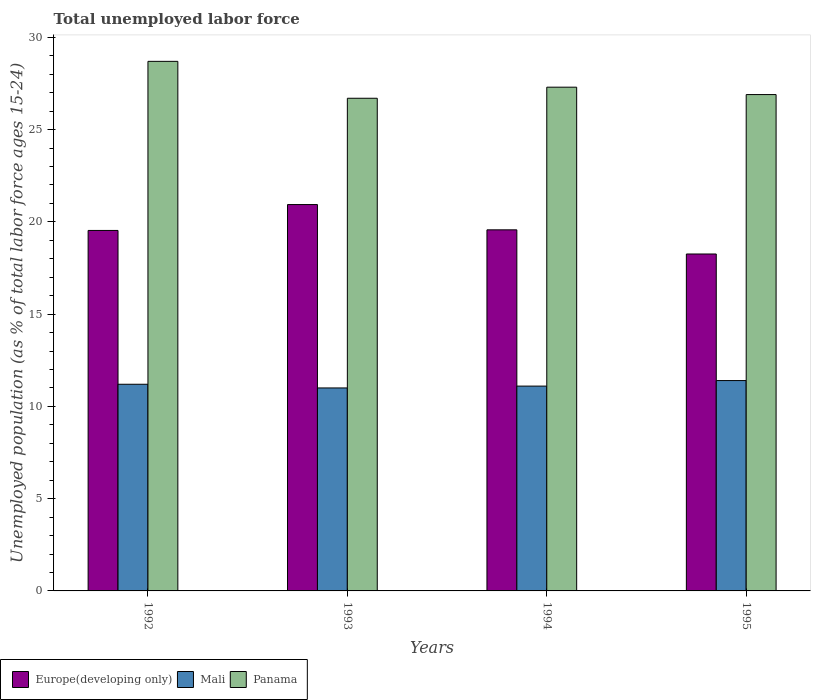How many groups of bars are there?
Provide a succinct answer. 4. Are the number of bars per tick equal to the number of legend labels?
Keep it short and to the point. Yes. Are the number of bars on each tick of the X-axis equal?
Provide a succinct answer. Yes. How many bars are there on the 3rd tick from the right?
Ensure brevity in your answer.  3. What is the label of the 4th group of bars from the left?
Offer a very short reply. 1995. In how many cases, is the number of bars for a given year not equal to the number of legend labels?
Give a very brief answer. 0. What is the percentage of unemployed population in in Europe(developing only) in 1994?
Make the answer very short. 19.57. Across all years, what is the maximum percentage of unemployed population in in Europe(developing only)?
Give a very brief answer. 20.94. Across all years, what is the minimum percentage of unemployed population in in Panama?
Your answer should be very brief. 26.7. In which year was the percentage of unemployed population in in Europe(developing only) maximum?
Give a very brief answer. 1993. In which year was the percentage of unemployed population in in Panama minimum?
Make the answer very short. 1993. What is the total percentage of unemployed population in in Mali in the graph?
Offer a terse response. 44.7. What is the difference between the percentage of unemployed population in in Mali in 1994 and that in 1995?
Provide a short and direct response. -0.3. What is the difference between the percentage of unemployed population in in Europe(developing only) in 1992 and the percentage of unemployed population in in Panama in 1994?
Provide a succinct answer. -7.76. What is the average percentage of unemployed population in in Mali per year?
Give a very brief answer. 11.17. In the year 1993, what is the difference between the percentage of unemployed population in in Europe(developing only) and percentage of unemployed population in in Mali?
Offer a very short reply. 9.94. In how many years, is the percentage of unemployed population in in Europe(developing only) greater than 25 %?
Keep it short and to the point. 0. What is the ratio of the percentage of unemployed population in in Mali in 1993 to that in 1994?
Provide a short and direct response. 0.99. What is the difference between the highest and the second highest percentage of unemployed population in in Panama?
Offer a terse response. 1.4. What is the difference between the highest and the lowest percentage of unemployed population in in Mali?
Give a very brief answer. 0.4. Is the sum of the percentage of unemployed population in in Panama in 1992 and 1993 greater than the maximum percentage of unemployed population in in Europe(developing only) across all years?
Your response must be concise. Yes. What does the 2nd bar from the left in 1995 represents?
Offer a terse response. Mali. What does the 1st bar from the right in 1995 represents?
Ensure brevity in your answer.  Panama. Is it the case that in every year, the sum of the percentage of unemployed population in in Europe(developing only) and percentage of unemployed population in in Panama is greater than the percentage of unemployed population in in Mali?
Your answer should be compact. Yes. Are all the bars in the graph horizontal?
Your answer should be very brief. No. Are the values on the major ticks of Y-axis written in scientific E-notation?
Give a very brief answer. No. Does the graph contain any zero values?
Ensure brevity in your answer.  No. What is the title of the graph?
Ensure brevity in your answer.  Total unemployed labor force. Does "Micronesia" appear as one of the legend labels in the graph?
Your response must be concise. No. What is the label or title of the X-axis?
Your answer should be compact. Years. What is the label or title of the Y-axis?
Your answer should be compact. Unemployed population (as % of total labor force ages 15-24). What is the Unemployed population (as % of total labor force ages 15-24) in Europe(developing only) in 1992?
Provide a succinct answer. 19.54. What is the Unemployed population (as % of total labor force ages 15-24) in Mali in 1992?
Ensure brevity in your answer.  11.2. What is the Unemployed population (as % of total labor force ages 15-24) of Panama in 1992?
Your answer should be compact. 28.7. What is the Unemployed population (as % of total labor force ages 15-24) in Europe(developing only) in 1993?
Keep it short and to the point. 20.94. What is the Unemployed population (as % of total labor force ages 15-24) in Panama in 1993?
Give a very brief answer. 26.7. What is the Unemployed population (as % of total labor force ages 15-24) in Europe(developing only) in 1994?
Provide a succinct answer. 19.57. What is the Unemployed population (as % of total labor force ages 15-24) of Mali in 1994?
Your answer should be very brief. 11.1. What is the Unemployed population (as % of total labor force ages 15-24) in Panama in 1994?
Offer a terse response. 27.3. What is the Unemployed population (as % of total labor force ages 15-24) in Europe(developing only) in 1995?
Offer a terse response. 18.26. What is the Unemployed population (as % of total labor force ages 15-24) of Mali in 1995?
Your answer should be compact. 11.4. What is the Unemployed population (as % of total labor force ages 15-24) of Panama in 1995?
Your answer should be very brief. 26.9. Across all years, what is the maximum Unemployed population (as % of total labor force ages 15-24) of Europe(developing only)?
Make the answer very short. 20.94. Across all years, what is the maximum Unemployed population (as % of total labor force ages 15-24) of Mali?
Your response must be concise. 11.4. Across all years, what is the maximum Unemployed population (as % of total labor force ages 15-24) in Panama?
Your answer should be very brief. 28.7. Across all years, what is the minimum Unemployed population (as % of total labor force ages 15-24) in Europe(developing only)?
Your answer should be compact. 18.26. Across all years, what is the minimum Unemployed population (as % of total labor force ages 15-24) of Panama?
Your answer should be compact. 26.7. What is the total Unemployed population (as % of total labor force ages 15-24) in Europe(developing only) in the graph?
Your response must be concise. 78.3. What is the total Unemployed population (as % of total labor force ages 15-24) in Mali in the graph?
Keep it short and to the point. 44.7. What is the total Unemployed population (as % of total labor force ages 15-24) in Panama in the graph?
Your answer should be very brief. 109.6. What is the difference between the Unemployed population (as % of total labor force ages 15-24) in Europe(developing only) in 1992 and that in 1993?
Offer a terse response. -1.4. What is the difference between the Unemployed population (as % of total labor force ages 15-24) in Mali in 1992 and that in 1993?
Your answer should be very brief. 0.2. What is the difference between the Unemployed population (as % of total labor force ages 15-24) of Europe(developing only) in 1992 and that in 1994?
Offer a terse response. -0.03. What is the difference between the Unemployed population (as % of total labor force ages 15-24) of Mali in 1992 and that in 1994?
Give a very brief answer. 0.1. What is the difference between the Unemployed population (as % of total labor force ages 15-24) in Panama in 1992 and that in 1994?
Your answer should be very brief. 1.4. What is the difference between the Unemployed population (as % of total labor force ages 15-24) in Europe(developing only) in 1992 and that in 1995?
Offer a very short reply. 1.28. What is the difference between the Unemployed population (as % of total labor force ages 15-24) in Panama in 1992 and that in 1995?
Make the answer very short. 1.8. What is the difference between the Unemployed population (as % of total labor force ages 15-24) of Europe(developing only) in 1993 and that in 1994?
Offer a very short reply. 1.37. What is the difference between the Unemployed population (as % of total labor force ages 15-24) in Panama in 1993 and that in 1994?
Give a very brief answer. -0.6. What is the difference between the Unemployed population (as % of total labor force ages 15-24) in Europe(developing only) in 1993 and that in 1995?
Offer a terse response. 2.68. What is the difference between the Unemployed population (as % of total labor force ages 15-24) in Panama in 1993 and that in 1995?
Offer a very short reply. -0.2. What is the difference between the Unemployed population (as % of total labor force ages 15-24) of Europe(developing only) in 1994 and that in 1995?
Your answer should be very brief. 1.31. What is the difference between the Unemployed population (as % of total labor force ages 15-24) of Panama in 1994 and that in 1995?
Your response must be concise. 0.4. What is the difference between the Unemployed population (as % of total labor force ages 15-24) in Europe(developing only) in 1992 and the Unemployed population (as % of total labor force ages 15-24) in Mali in 1993?
Give a very brief answer. 8.54. What is the difference between the Unemployed population (as % of total labor force ages 15-24) of Europe(developing only) in 1992 and the Unemployed population (as % of total labor force ages 15-24) of Panama in 1993?
Provide a succinct answer. -7.16. What is the difference between the Unemployed population (as % of total labor force ages 15-24) of Mali in 1992 and the Unemployed population (as % of total labor force ages 15-24) of Panama in 1993?
Offer a very short reply. -15.5. What is the difference between the Unemployed population (as % of total labor force ages 15-24) in Europe(developing only) in 1992 and the Unemployed population (as % of total labor force ages 15-24) in Mali in 1994?
Give a very brief answer. 8.44. What is the difference between the Unemployed population (as % of total labor force ages 15-24) in Europe(developing only) in 1992 and the Unemployed population (as % of total labor force ages 15-24) in Panama in 1994?
Your answer should be compact. -7.76. What is the difference between the Unemployed population (as % of total labor force ages 15-24) in Mali in 1992 and the Unemployed population (as % of total labor force ages 15-24) in Panama in 1994?
Make the answer very short. -16.1. What is the difference between the Unemployed population (as % of total labor force ages 15-24) in Europe(developing only) in 1992 and the Unemployed population (as % of total labor force ages 15-24) in Mali in 1995?
Your response must be concise. 8.14. What is the difference between the Unemployed population (as % of total labor force ages 15-24) in Europe(developing only) in 1992 and the Unemployed population (as % of total labor force ages 15-24) in Panama in 1995?
Offer a terse response. -7.36. What is the difference between the Unemployed population (as % of total labor force ages 15-24) in Mali in 1992 and the Unemployed population (as % of total labor force ages 15-24) in Panama in 1995?
Keep it short and to the point. -15.7. What is the difference between the Unemployed population (as % of total labor force ages 15-24) of Europe(developing only) in 1993 and the Unemployed population (as % of total labor force ages 15-24) of Mali in 1994?
Provide a succinct answer. 9.84. What is the difference between the Unemployed population (as % of total labor force ages 15-24) in Europe(developing only) in 1993 and the Unemployed population (as % of total labor force ages 15-24) in Panama in 1994?
Offer a terse response. -6.36. What is the difference between the Unemployed population (as % of total labor force ages 15-24) of Mali in 1993 and the Unemployed population (as % of total labor force ages 15-24) of Panama in 1994?
Make the answer very short. -16.3. What is the difference between the Unemployed population (as % of total labor force ages 15-24) of Europe(developing only) in 1993 and the Unemployed population (as % of total labor force ages 15-24) of Mali in 1995?
Provide a short and direct response. 9.54. What is the difference between the Unemployed population (as % of total labor force ages 15-24) in Europe(developing only) in 1993 and the Unemployed population (as % of total labor force ages 15-24) in Panama in 1995?
Your response must be concise. -5.96. What is the difference between the Unemployed population (as % of total labor force ages 15-24) in Mali in 1993 and the Unemployed population (as % of total labor force ages 15-24) in Panama in 1995?
Offer a terse response. -15.9. What is the difference between the Unemployed population (as % of total labor force ages 15-24) of Europe(developing only) in 1994 and the Unemployed population (as % of total labor force ages 15-24) of Mali in 1995?
Your answer should be very brief. 8.17. What is the difference between the Unemployed population (as % of total labor force ages 15-24) of Europe(developing only) in 1994 and the Unemployed population (as % of total labor force ages 15-24) of Panama in 1995?
Offer a very short reply. -7.33. What is the difference between the Unemployed population (as % of total labor force ages 15-24) of Mali in 1994 and the Unemployed population (as % of total labor force ages 15-24) of Panama in 1995?
Ensure brevity in your answer.  -15.8. What is the average Unemployed population (as % of total labor force ages 15-24) in Europe(developing only) per year?
Offer a terse response. 19.58. What is the average Unemployed population (as % of total labor force ages 15-24) of Mali per year?
Make the answer very short. 11.18. What is the average Unemployed population (as % of total labor force ages 15-24) in Panama per year?
Your response must be concise. 27.4. In the year 1992, what is the difference between the Unemployed population (as % of total labor force ages 15-24) of Europe(developing only) and Unemployed population (as % of total labor force ages 15-24) of Mali?
Give a very brief answer. 8.34. In the year 1992, what is the difference between the Unemployed population (as % of total labor force ages 15-24) in Europe(developing only) and Unemployed population (as % of total labor force ages 15-24) in Panama?
Make the answer very short. -9.16. In the year 1992, what is the difference between the Unemployed population (as % of total labor force ages 15-24) of Mali and Unemployed population (as % of total labor force ages 15-24) of Panama?
Provide a short and direct response. -17.5. In the year 1993, what is the difference between the Unemployed population (as % of total labor force ages 15-24) of Europe(developing only) and Unemployed population (as % of total labor force ages 15-24) of Mali?
Keep it short and to the point. 9.94. In the year 1993, what is the difference between the Unemployed population (as % of total labor force ages 15-24) in Europe(developing only) and Unemployed population (as % of total labor force ages 15-24) in Panama?
Your response must be concise. -5.76. In the year 1993, what is the difference between the Unemployed population (as % of total labor force ages 15-24) of Mali and Unemployed population (as % of total labor force ages 15-24) of Panama?
Provide a succinct answer. -15.7. In the year 1994, what is the difference between the Unemployed population (as % of total labor force ages 15-24) of Europe(developing only) and Unemployed population (as % of total labor force ages 15-24) of Mali?
Give a very brief answer. 8.47. In the year 1994, what is the difference between the Unemployed population (as % of total labor force ages 15-24) of Europe(developing only) and Unemployed population (as % of total labor force ages 15-24) of Panama?
Make the answer very short. -7.73. In the year 1994, what is the difference between the Unemployed population (as % of total labor force ages 15-24) in Mali and Unemployed population (as % of total labor force ages 15-24) in Panama?
Give a very brief answer. -16.2. In the year 1995, what is the difference between the Unemployed population (as % of total labor force ages 15-24) in Europe(developing only) and Unemployed population (as % of total labor force ages 15-24) in Mali?
Offer a terse response. 6.86. In the year 1995, what is the difference between the Unemployed population (as % of total labor force ages 15-24) in Europe(developing only) and Unemployed population (as % of total labor force ages 15-24) in Panama?
Your response must be concise. -8.64. In the year 1995, what is the difference between the Unemployed population (as % of total labor force ages 15-24) in Mali and Unemployed population (as % of total labor force ages 15-24) in Panama?
Provide a succinct answer. -15.5. What is the ratio of the Unemployed population (as % of total labor force ages 15-24) in Europe(developing only) in 1992 to that in 1993?
Ensure brevity in your answer.  0.93. What is the ratio of the Unemployed population (as % of total labor force ages 15-24) in Mali in 1992 to that in 1993?
Keep it short and to the point. 1.02. What is the ratio of the Unemployed population (as % of total labor force ages 15-24) in Panama in 1992 to that in 1993?
Your answer should be very brief. 1.07. What is the ratio of the Unemployed population (as % of total labor force ages 15-24) in Europe(developing only) in 1992 to that in 1994?
Offer a very short reply. 1. What is the ratio of the Unemployed population (as % of total labor force ages 15-24) of Panama in 1992 to that in 1994?
Provide a succinct answer. 1.05. What is the ratio of the Unemployed population (as % of total labor force ages 15-24) in Europe(developing only) in 1992 to that in 1995?
Ensure brevity in your answer.  1.07. What is the ratio of the Unemployed population (as % of total labor force ages 15-24) in Mali in 1992 to that in 1995?
Offer a very short reply. 0.98. What is the ratio of the Unemployed population (as % of total labor force ages 15-24) in Panama in 1992 to that in 1995?
Make the answer very short. 1.07. What is the ratio of the Unemployed population (as % of total labor force ages 15-24) in Europe(developing only) in 1993 to that in 1994?
Provide a short and direct response. 1.07. What is the ratio of the Unemployed population (as % of total labor force ages 15-24) in Mali in 1993 to that in 1994?
Provide a succinct answer. 0.99. What is the ratio of the Unemployed population (as % of total labor force ages 15-24) in Europe(developing only) in 1993 to that in 1995?
Keep it short and to the point. 1.15. What is the ratio of the Unemployed population (as % of total labor force ages 15-24) in Mali in 1993 to that in 1995?
Make the answer very short. 0.96. What is the ratio of the Unemployed population (as % of total labor force ages 15-24) of Europe(developing only) in 1994 to that in 1995?
Your response must be concise. 1.07. What is the ratio of the Unemployed population (as % of total labor force ages 15-24) in Mali in 1994 to that in 1995?
Provide a succinct answer. 0.97. What is the ratio of the Unemployed population (as % of total labor force ages 15-24) of Panama in 1994 to that in 1995?
Your response must be concise. 1.01. What is the difference between the highest and the second highest Unemployed population (as % of total labor force ages 15-24) of Europe(developing only)?
Provide a succinct answer. 1.37. What is the difference between the highest and the second highest Unemployed population (as % of total labor force ages 15-24) of Panama?
Provide a short and direct response. 1.4. What is the difference between the highest and the lowest Unemployed population (as % of total labor force ages 15-24) of Europe(developing only)?
Your answer should be very brief. 2.68. 